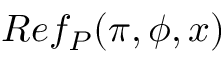<formula> <loc_0><loc_0><loc_500><loc_500>R e f _ { P } ( \pi , \phi , x )</formula> 